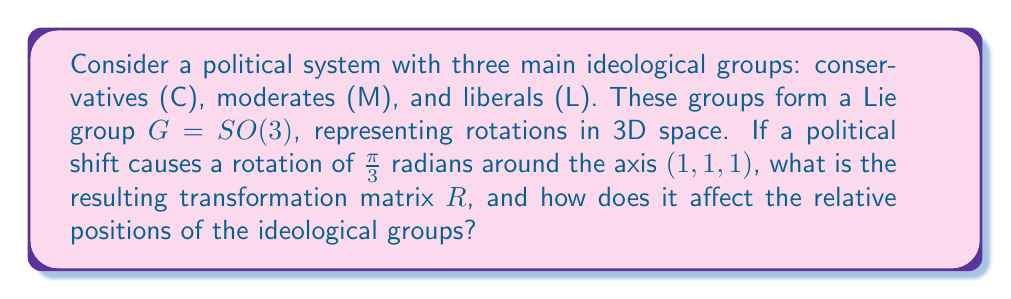Give your solution to this math problem. 1) The rotation matrix for a rotation of angle $\theta$ around an axis $\mathbf{u} = (u_x, u_y, u_z)$ is given by:

   $$R = \begin{pmatrix}
   \cos\theta + u_x^2(1-\cos\theta) & u_xu_y(1-\cos\theta) - u_z\sin\theta & u_xu_z(1-\cos\theta) + u_y\sin\theta \\
   u_yu_x(1-\cos\theta) + u_z\sin\theta & \cos\theta + u_y^2(1-\cos\theta) & u_yu_z(1-\cos\theta) - u_x\sin\theta \\
   u_zu_x(1-\cos\theta) - u_y\sin\theta & u_zu_y(1-\cos\theta) + u_x\sin\theta & \cos\theta + u_z^2(1-\cos\theta)
   \end{pmatrix}$$

2) In this case, $\theta = \frac{\pi}{3}$ and $\mathbf{u} = (1, 1, 1)$. We need to normalize $\mathbf{u}$:

   $$\mathbf{u} = \frac{1}{\sqrt{3}}(1, 1, 1)$$

3) Substituting the values:

   $\cos\theta = \cos(\frac{\pi}{3}) = \frac{1}{2}$
   $\sin\theta = \sin(\frac{\pi}{3}) = \frac{\sqrt{3}}{2}$
   $u_x = u_y = u_z = \frac{1}{\sqrt{3}}$

4) Calculating the matrix elements:

   $R_{11} = R_{22} = R_{33} = \frac{1}{2} + \frac{1}{3}(1-\frac{1}{2}) = \frac{2}{3}$

   $R_{12} = R_{23} = R_{31} = \frac{1}{3}(1-\frac{1}{2}) - \frac{1}{\sqrt{3}}\frac{\sqrt{3}}{2} = -\frac{1}{3}$

   $R_{21} = R_{32} = R_{13} = \frac{1}{3}(1-\frac{1}{2}) + \frac{1}{\sqrt{3}}\frac{\sqrt{3}}{2} = \frac{2}{3}$

5) The resulting transformation matrix is:

   $$R = \begin{pmatrix}
   \frac{2}{3} & -\frac{1}{3} & \frac{2}{3} \\
   \frac{2}{3} & \frac{2}{3} & -\frac{1}{3} \\
   -\frac{1}{3} & \frac{2}{3} & \frac{2}{3}
   \end{pmatrix}$$

6) To interpret this politically:
   - The diagonal elements being positive and equal indicates that each group retains some of its original character.
   - The off-diagonal elements show how each group influences the others. For example, conservatives now have a negative influence on moderates but a positive influence on liberals.
   - The asymmetry in the matrix suggests a cyclical shift in ideologies, potentially leading to a realignment of political coalitions.
Answer: $R = \begin{pmatrix}
\frac{2}{3} & -\frac{1}{3} & \frac{2}{3} \\
\frac{2}{3} & \frac{2}{3} & -\frac{1}{3} \\
-\frac{1}{3} & \frac{2}{3} & \frac{2}{3}
\end{pmatrix}$; cyclical ideological shift 